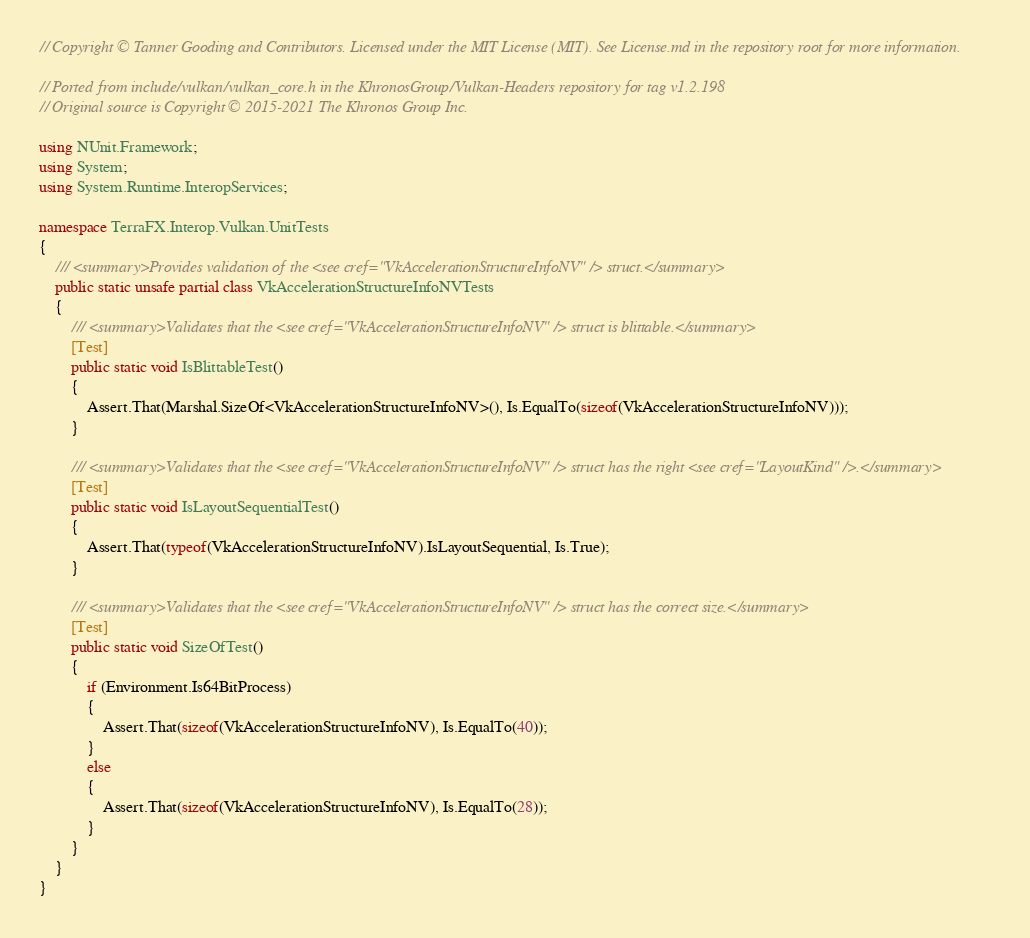Convert code to text. <code><loc_0><loc_0><loc_500><loc_500><_C#_>// Copyright © Tanner Gooding and Contributors. Licensed under the MIT License (MIT). See License.md in the repository root for more information.

// Ported from include/vulkan/vulkan_core.h in the KhronosGroup/Vulkan-Headers repository for tag v1.2.198
// Original source is Copyright © 2015-2021 The Khronos Group Inc.

using NUnit.Framework;
using System;
using System.Runtime.InteropServices;

namespace TerraFX.Interop.Vulkan.UnitTests
{
    /// <summary>Provides validation of the <see cref="VkAccelerationStructureInfoNV" /> struct.</summary>
    public static unsafe partial class VkAccelerationStructureInfoNVTests
    {
        /// <summary>Validates that the <see cref="VkAccelerationStructureInfoNV" /> struct is blittable.</summary>
        [Test]
        public static void IsBlittableTest()
        {
            Assert.That(Marshal.SizeOf<VkAccelerationStructureInfoNV>(), Is.EqualTo(sizeof(VkAccelerationStructureInfoNV)));
        }

        /// <summary>Validates that the <see cref="VkAccelerationStructureInfoNV" /> struct has the right <see cref="LayoutKind" />.</summary>
        [Test]
        public static void IsLayoutSequentialTest()
        {
            Assert.That(typeof(VkAccelerationStructureInfoNV).IsLayoutSequential, Is.True);
        }

        /// <summary>Validates that the <see cref="VkAccelerationStructureInfoNV" /> struct has the correct size.</summary>
        [Test]
        public static void SizeOfTest()
        {
            if (Environment.Is64BitProcess)
            {
                Assert.That(sizeof(VkAccelerationStructureInfoNV), Is.EqualTo(40));
            }
            else
            {
                Assert.That(sizeof(VkAccelerationStructureInfoNV), Is.EqualTo(28));
            }
        }
    }
}
</code> 